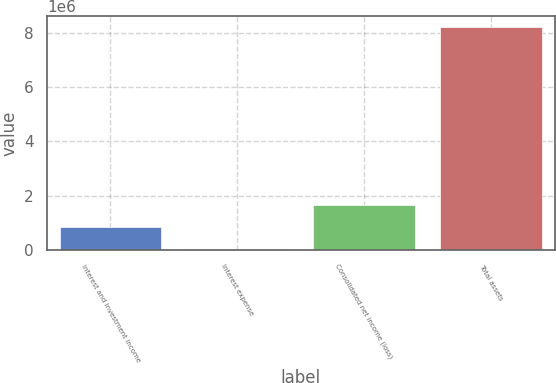Convert chart. <chart><loc_0><loc_0><loc_500><loc_500><bar_chart><fcel>Interest and investment income<fcel>Interest expense<fcel>Consolidated net income (loss)<fcel>Total assets<nl><fcel>845128<fcel>26788<fcel>1.66347e+06<fcel>8.21018e+06<nl></chart> 